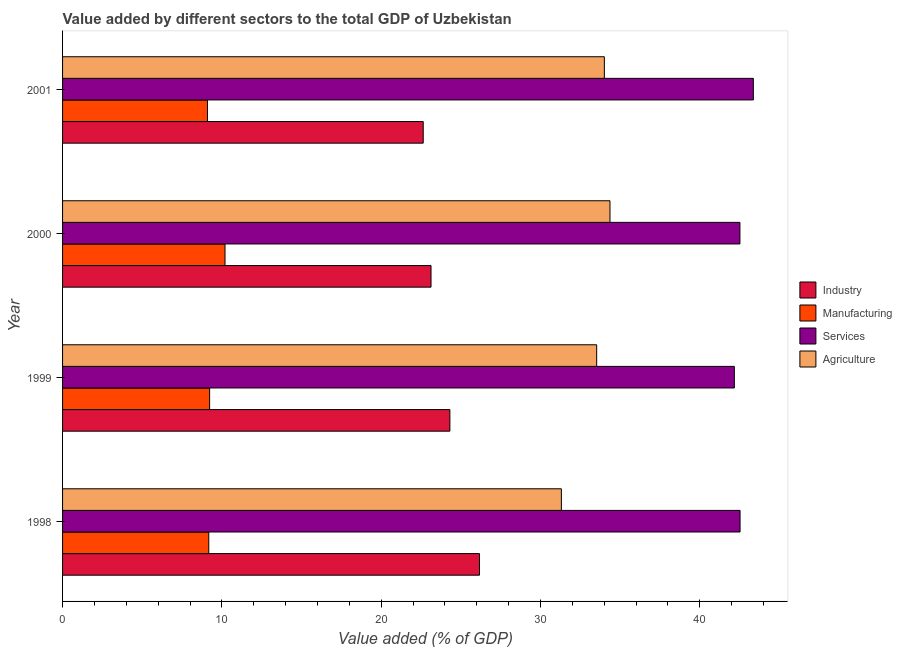How many groups of bars are there?
Give a very brief answer. 4. Are the number of bars per tick equal to the number of legend labels?
Your answer should be very brief. Yes. Are the number of bars on each tick of the Y-axis equal?
Your response must be concise. Yes. How many bars are there on the 3rd tick from the top?
Give a very brief answer. 4. What is the label of the 4th group of bars from the top?
Ensure brevity in your answer.  1998. In how many cases, is the number of bars for a given year not equal to the number of legend labels?
Keep it short and to the point. 0. What is the value added by services sector in 2001?
Offer a terse response. 43.36. Across all years, what is the maximum value added by agricultural sector?
Offer a terse response. 34.36. Across all years, what is the minimum value added by agricultural sector?
Your answer should be compact. 31.31. What is the total value added by agricultural sector in the graph?
Offer a terse response. 133.2. What is the difference between the value added by manufacturing sector in 1998 and that in 2000?
Ensure brevity in your answer.  -1.02. What is the difference between the value added by industrial sector in 2001 and the value added by manufacturing sector in 1998?
Give a very brief answer. 13.46. What is the average value added by manufacturing sector per year?
Offer a terse response. 9.43. In the year 2000, what is the difference between the value added by services sector and value added by manufacturing sector?
Keep it short and to the point. 32.32. In how many years, is the value added by industrial sector greater than 2 %?
Your answer should be very brief. 4. What is the ratio of the value added by agricultural sector in 2000 to that in 2001?
Your answer should be very brief. 1.01. Is the value added by industrial sector in 1998 less than that in 1999?
Your answer should be very brief. No. What is the difference between the highest and the lowest value added by services sector?
Provide a short and direct response. 1.19. In how many years, is the value added by agricultural sector greater than the average value added by agricultural sector taken over all years?
Make the answer very short. 3. Is it the case that in every year, the sum of the value added by services sector and value added by manufacturing sector is greater than the sum of value added by industrial sector and value added by agricultural sector?
Provide a succinct answer. No. What does the 2nd bar from the top in 1998 represents?
Ensure brevity in your answer.  Services. What does the 1st bar from the bottom in 2001 represents?
Ensure brevity in your answer.  Industry. Are all the bars in the graph horizontal?
Your answer should be compact. Yes. How many years are there in the graph?
Give a very brief answer. 4. What is the difference between two consecutive major ticks on the X-axis?
Offer a terse response. 10. Does the graph contain any zero values?
Offer a terse response. No. Does the graph contain grids?
Offer a terse response. No. Where does the legend appear in the graph?
Your answer should be very brief. Center right. What is the title of the graph?
Provide a succinct answer. Value added by different sectors to the total GDP of Uzbekistan. Does "UNDP" appear as one of the legend labels in the graph?
Offer a very short reply. No. What is the label or title of the X-axis?
Offer a very short reply. Value added (% of GDP). What is the label or title of the Y-axis?
Ensure brevity in your answer.  Year. What is the Value added (% of GDP) in Industry in 1998?
Provide a succinct answer. 26.17. What is the Value added (% of GDP) of Manufacturing in 1998?
Make the answer very short. 9.18. What is the Value added (% of GDP) of Services in 1998?
Give a very brief answer. 42.52. What is the Value added (% of GDP) of Agriculture in 1998?
Make the answer very short. 31.31. What is the Value added (% of GDP) of Industry in 1999?
Provide a succinct answer. 24.31. What is the Value added (% of GDP) of Manufacturing in 1999?
Provide a short and direct response. 9.23. What is the Value added (% of GDP) of Services in 1999?
Make the answer very short. 42.17. What is the Value added (% of GDP) in Agriculture in 1999?
Keep it short and to the point. 33.52. What is the Value added (% of GDP) in Industry in 2000?
Offer a terse response. 23.13. What is the Value added (% of GDP) in Manufacturing in 2000?
Provide a succinct answer. 10.2. What is the Value added (% of GDP) of Services in 2000?
Make the answer very short. 42.51. What is the Value added (% of GDP) of Agriculture in 2000?
Make the answer very short. 34.36. What is the Value added (% of GDP) of Industry in 2001?
Your response must be concise. 22.64. What is the Value added (% of GDP) in Manufacturing in 2001?
Offer a very short reply. 9.1. What is the Value added (% of GDP) in Services in 2001?
Ensure brevity in your answer.  43.36. What is the Value added (% of GDP) in Agriculture in 2001?
Your answer should be very brief. 34.01. Across all years, what is the maximum Value added (% of GDP) in Industry?
Offer a terse response. 26.17. Across all years, what is the maximum Value added (% of GDP) in Manufacturing?
Your answer should be very brief. 10.2. Across all years, what is the maximum Value added (% of GDP) in Services?
Your answer should be very brief. 43.36. Across all years, what is the maximum Value added (% of GDP) in Agriculture?
Keep it short and to the point. 34.36. Across all years, what is the minimum Value added (% of GDP) of Industry?
Make the answer very short. 22.64. Across all years, what is the minimum Value added (% of GDP) in Manufacturing?
Your answer should be very brief. 9.1. Across all years, what is the minimum Value added (% of GDP) of Services?
Offer a terse response. 42.17. Across all years, what is the minimum Value added (% of GDP) of Agriculture?
Give a very brief answer. 31.31. What is the total Value added (% of GDP) in Industry in the graph?
Your answer should be very brief. 96.24. What is the total Value added (% of GDP) in Manufacturing in the graph?
Your answer should be compact. 37.7. What is the total Value added (% of GDP) of Services in the graph?
Make the answer very short. 170.56. What is the total Value added (% of GDP) in Agriculture in the graph?
Offer a terse response. 133.2. What is the difference between the Value added (% of GDP) in Industry in 1998 and that in 1999?
Ensure brevity in your answer.  1.86. What is the difference between the Value added (% of GDP) of Manufacturing in 1998 and that in 1999?
Your answer should be very brief. -0.05. What is the difference between the Value added (% of GDP) in Services in 1998 and that in 1999?
Your answer should be compact. 0.36. What is the difference between the Value added (% of GDP) in Agriculture in 1998 and that in 1999?
Give a very brief answer. -2.22. What is the difference between the Value added (% of GDP) in Industry in 1998 and that in 2000?
Provide a short and direct response. 3.04. What is the difference between the Value added (% of GDP) in Manufacturing in 1998 and that in 2000?
Keep it short and to the point. -1.02. What is the difference between the Value added (% of GDP) in Services in 1998 and that in 2000?
Provide a short and direct response. 0.01. What is the difference between the Value added (% of GDP) in Agriculture in 1998 and that in 2000?
Offer a very short reply. -3.05. What is the difference between the Value added (% of GDP) of Industry in 1998 and that in 2001?
Offer a very short reply. 3.53. What is the difference between the Value added (% of GDP) of Manufacturing in 1998 and that in 2001?
Give a very brief answer. 0.08. What is the difference between the Value added (% of GDP) in Services in 1998 and that in 2001?
Give a very brief answer. -0.83. What is the difference between the Value added (% of GDP) in Agriculture in 1998 and that in 2001?
Provide a short and direct response. -2.7. What is the difference between the Value added (% of GDP) of Industry in 1999 and that in 2000?
Offer a very short reply. 1.18. What is the difference between the Value added (% of GDP) of Manufacturing in 1999 and that in 2000?
Your response must be concise. -0.97. What is the difference between the Value added (% of GDP) in Services in 1999 and that in 2000?
Give a very brief answer. -0.35. What is the difference between the Value added (% of GDP) in Agriculture in 1999 and that in 2000?
Make the answer very short. -0.84. What is the difference between the Value added (% of GDP) of Industry in 1999 and that in 2001?
Keep it short and to the point. 1.67. What is the difference between the Value added (% of GDP) in Manufacturing in 1999 and that in 2001?
Your answer should be compact. 0.13. What is the difference between the Value added (% of GDP) in Services in 1999 and that in 2001?
Your response must be concise. -1.19. What is the difference between the Value added (% of GDP) of Agriculture in 1999 and that in 2001?
Offer a very short reply. -0.48. What is the difference between the Value added (% of GDP) of Industry in 2000 and that in 2001?
Offer a terse response. 0.49. What is the difference between the Value added (% of GDP) in Manufacturing in 2000 and that in 2001?
Provide a short and direct response. 1.1. What is the difference between the Value added (% of GDP) in Services in 2000 and that in 2001?
Your answer should be compact. -0.84. What is the difference between the Value added (% of GDP) in Agriculture in 2000 and that in 2001?
Offer a terse response. 0.35. What is the difference between the Value added (% of GDP) of Industry in 1998 and the Value added (% of GDP) of Manufacturing in 1999?
Provide a short and direct response. 16.94. What is the difference between the Value added (% of GDP) of Industry in 1998 and the Value added (% of GDP) of Services in 1999?
Give a very brief answer. -16. What is the difference between the Value added (% of GDP) of Industry in 1998 and the Value added (% of GDP) of Agriculture in 1999?
Your answer should be compact. -7.36. What is the difference between the Value added (% of GDP) in Manufacturing in 1998 and the Value added (% of GDP) in Services in 1999?
Give a very brief answer. -32.99. What is the difference between the Value added (% of GDP) in Manufacturing in 1998 and the Value added (% of GDP) in Agriculture in 1999?
Make the answer very short. -24.35. What is the difference between the Value added (% of GDP) in Services in 1998 and the Value added (% of GDP) in Agriculture in 1999?
Keep it short and to the point. 9. What is the difference between the Value added (% of GDP) in Industry in 1998 and the Value added (% of GDP) in Manufacturing in 2000?
Keep it short and to the point. 15.97. What is the difference between the Value added (% of GDP) of Industry in 1998 and the Value added (% of GDP) of Services in 2000?
Your answer should be compact. -16.35. What is the difference between the Value added (% of GDP) of Industry in 1998 and the Value added (% of GDP) of Agriculture in 2000?
Your response must be concise. -8.19. What is the difference between the Value added (% of GDP) of Manufacturing in 1998 and the Value added (% of GDP) of Services in 2000?
Provide a short and direct response. -33.34. What is the difference between the Value added (% of GDP) of Manufacturing in 1998 and the Value added (% of GDP) of Agriculture in 2000?
Your answer should be compact. -25.18. What is the difference between the Value added (% of GDP) of Services in 1998 and the Value added (% of GDP) of Agriculture in 2000?
Ensure brevity in your answer.  8.16. What is the difference between the Value added (% of GDP) in Industry in 1998 and the Value added (% of GDP) in Manufacturing in 2001?
Keep it short and to the point. 17.07. What is the difference between the Value added (% of GDP) of Industry in 1998 and the Value added (% of GDP) of Services in 2001?
Offer a very short reply. -17.19. What is the difference between the Value added (% of GDP) in Industry in 1998 and the Value added (% of GDP) in Agriculture in 2001?
Ensure brevity in your answer.  -7.84. What is the difference between the Value added (% of GDP) of Manufacturing in 1998 and the Value added (% of GDP) of Services in 2001?
Your response must be concise. -34.18. What is the difference between the Value added (% of GDP) in Manufacturing in 1998 and the Value added (% of GDP) in Agriculture in 2001?
Your answer should be very brief. -24.83. What is the difference between the Value added (% of GDP) of Services in 1998 and the Value added (% of GDP) of Agriculture in 2001?
Your answer should be very brief. 8.52. What is the difference between the Value added (% of GDP) of Industry in 1999 and the Value added (% of GDP) of Manufacturing in 2000?
Make the answer very short. 14.11. What is the difference between the Value added (% of GDP) of Industry in 1999 and the Value added (% of GDP) of Services in 2000?
Make the answer very short. -18.2. What is the difference between the Value added (% of GDP) of Industry in 1999 and the Value added (% of GDP) of Agriculture in 2000?
Provide a short and direct response. -10.05. What is the difference between the Value added (% of GDP) in Manufacturing in 1999 and the Value added (% of GDP) in Services in 2000?
Make the answer very short. -33.28. What is the difference between the Value added (% of GDP) in Manufacturing in 1999 and the Value added (% of GDP) in Agriculture in 2000?
Keep it short and to the point. -25.13. What is the difference between the Value added (% of GDP) of Services in 1999 and the Value added (% of GDP) of Agriculture in 2000?
Offer a very short reply. 7.81. What is the difference between the Value added (% of GDP) of Industry in 1999 and the Value added (% of GDP) of Manufacturing in 2001?
Your answer should be very brief. 15.21. What is the difference between the Value added (% of GDP) of Industry in 1999 and the Value added (% of GDP) of Services in 2001?
Your response must be concise. -19.05. What is the difference between the Value added (% of GDP) in Industry in 1999 and the Value added (% of GDP) in Agriculture in 2001?
Keep it short and to the point. -9.7. What is the difference between the Value added (% of GDP) of Manufacturing in 1999 and the Value added (% of GDP) of Services in 2001?
Your answer should be compact. -34.13. What is the difference between the Value added (% of GDP) of Manufacturing in 1999 and the Value added (% of GDP) of Agriculture in 2001?
Your answer should be compact. -24.77. What is the difference between the Value added (% of GDP) of Services in 1999 and the Value added (% of GDP) of Agriculture in 2001?
Make the answer very short. 8.16. What is the difference between the Value added (% of GDP) of Industry in 2000 and the Value added (% of GDP) of Manufacturing in 2001?
Make the answer very short. 14.03. What is the difference between the Value added (% of GDP) of Industry in 2000 and the Value added (% of GDP) of Services in 2001?
Give a very brief answer. -20.23. What is the difference between the Value added (% of GDP) in Industry in 2000 and the Value added (% of GDP) in Agriculture in 2001?
Your response must be concise. -10.88. What is the difference between the Value added (% of GDP) of Manufacturing in 2000 and the Value added (% of GDP) of Services in 2001?
Give a very brief answer. -33.16. What is the difference between the Value added (% of GDP) of Manufacturing in 2000 and the Value added (% of GDP) of Agriculture in 2001?
Offer a terse response. -23.81. What is the difference between the Value added (% of GDP) in Services in 2000 and the Value added (% of GDP) in Agriculture in 2001?
Keep it short and to the point. 8.51. What is the average Value added (% of GDP) of Industry per year?
Your response must be concise. 24.06. What is the average Value added (% of GDP) in Manufacturing per year?
Your answer should be very brief. 9.43. What is the average Value added (% of GDP) in Services per year?
Your answer should be very brief. 42.64. What is the average Value added (% of GDP) of Agriculture per year?
Your answer should be compact. 33.3. In the year 1998, what is the difference between the Value added (% of GDP) of Industry and Value added (% of GDP) of Manufacturing?
Give a very brief answer. 16.99. In the year 1998, what is the difference between the Value added (% of GDP) of Industry and Value added (% of GDP) of Services?
Keep it short and to the point. -16.36. In the year 1998, what is the difference between the Value added (% of GDP) in Industry and Value added (% of GDP) in Agriculture?
Make the answer very short. -5.14. In the year 1998, what is the difference between the Value added (% of GDP) in Manufacturing and Value added (% of GDP) in Services?
Make the answer very short. -33.35. In the year 1998, what is the difference between the Value added (% of GDP) of Manufacturing and Value added (% of GDP) of Agriculture?
Make the answer very short. -22.13. In the year 1998, what is the difference between the Value added (% of GDP) in Services and Value added (% of GDP) in Agriculture?
Provide a short and direct response. 11.21. In the year 1999, what is the difference between the Value added (% of GDP) in Industry and Value added (% of GDP) in Manufacturing?
Your response must be concise. 15.08. In the year 1999, what is the difference between the Value added (% of GDP) of Industry and Value added (% of GDP) of Services?
Keep it short and to the point. -17.86. In the year 1999, what is the difference between the Value added (% of GDP) of Industry and Value added (% of GDP) of Agriculture?
Give a very brief answer. -9.21. In the year 1999, what is the difference between the Value added (% of GDP) of Manufacturing and Value added (% of GDP) of Services?
Your answer should be very brief. -32.94. In the year 1999, what is the difference between the Value added (% of GDP) in Manufacturing and Value added (% of GDP) in Agriculture?
Your response must be concise. -24.29. In the year 1999, what is the difference between the Value added (% of GDP) of Services and Value added (% of GDP) of Agriculture?
Ensure brevity in your answer.  8.64. In the year 2000, what is the difference between the Value added (% of GDP) in Industry and Value added (% of GDP) in Manufacturing?
Provide a short and direct response. 12.93. In the year 2000, what is the difference between the Value added (% of GDP) of Industry and Value added (% of GDP) of Services?
Provide a succinct answer. -19.39. In the year 2000, what is the difference between the Value added (% of GDP) in Industry and Value added (% of GDP) in Agriculture?
Offer a terse response. -11.23. In the year 2000, what is the difference between the Value added (% of GDP) in Manufacturing and Value added (% of GDP) in Services?
Give a very brief answer. -32.32. In the year 2000, what is the difference between the Value added (% of GDP) in Manufacturing and Value added (% of GDP) in Agriculture?
Provide a succinct answer. -24.16. In the year 2000, what is the difference between the Value added (% of GDP) in Services and Value added (% of GDP) in Agriculture?
Provide a short and direct response. 8.16. In the year 2001, what is the difference between the Value added (% of GDP) of Industry and Value added (% of GDP) of Manufacturing?
Ensure brevity in your answer.  13.54. In the year 2001, what is the difference between the Value added (% of GDP) of Industry and Value added (% of GDP) of Services?
Keep it short and to the point. -20.72. In the year 2001, what is the difference between the Value added (% of GDP) in Industry and Value added (% of GDP) in Agriculture?
Provide a short and direct response. -11.37. In the year 2001, what is the difference between the Value added (% of GDP) in Manufacturing and Value added (% of GDP) in Services?
Your answer should be very brief. -34.26. In the year 2001, what is the difference between the Value added (% of GDP) in Manufacturing and Value added (% of GDP) in Agriculture?
Offer a terse response. -24.91. In the year 2001, what is the difference between the Value added (% of GDP) of Services and Value added (% of GDP) of Agriculture?
Keep it short and to the point. 9.35. What is the ratio of the Value added (% of GDP) of Industry in 1998 to that in 1999?
Your response must be concise. 1.08. What is the ratio of the Value added (% of GDP) of Manufacturing in 1998 to that in 1999?
Make the answer very short. 0.99. What is the ratio of the Value added (% of GDP) in Services in 1998 to that in 1999?
Make the answer very short. 1.01. What is the ratio of the Value added (% of GDP) of Agriculture in 1998 to that in 1999?
Your response must be concise. 0.93. What is the ratio of the Value added (% of GDP) of Industry in 1998 to that in 2000?
Ensure brevity in your answer.  1.13. What is the ratio of the Value added (% of GDP) of Manufacturing in 1998 to that in 2000?
Your answer should be very brief. 0.9. What is the ratio of the Value added (% of GDP) of Services in 1998 to that in 2000?
Your response must be concise. 1. What is the ratio of the Value added (% of GDP) of Agriculture in 1998 to that in 2000?
Your response must be concise. 0.91. What is the ratio of the Value added (% of GDP) of Industry in 1998 to that in 2001?
Make the answer very short. 1.16. What is the ratio of the Value added (% of GDP) of Manufacturing in 1998 to that in 2001?
Give a very brief answer. 1.01. What is the ratio of the Value added (% of GDP) in Services in 1998 to that in 2001?
Offer a terse response. 0.98. What is the ratio of the Value added (% of GDP) in Agriculture in 1998 to that in 2001?
Keep it short and to the point. 0.92. What is the ratio of the Value added (% of GDP) in Industry in 1999 to that in 2000?
Your answer should be compact. 1.05. What is the ratio of the Value added (% of GDP) in Manufacturing in 1999 to that in 2000?
Offer a very short reply. 0.91. What is the ratio of the Value added (% of GDP) in Services in 1999 to that in 2000?
Your answer should be very brief. 0.99. What is the ratio of the Value added (% of GDP) of Agriculture in 1999 to that in 2000?
Your answer should be compact. 0.98. What is the ratio of the Value added (% of GDP) in Industry in 1999 to that in 2001?
Offer a very short reply. 1.07. What is the ratio of the Value added (% of GDP) in Manufacturing in 1999 to that in 2001?
Provide a succinct answer. 1.01. What is the ratio of the Value added (% of GDP) of Services in 1999 to that in 2001?
Provide a succinct answer. 0.97. What is the ratio of the Value added (% of GDP) of Agriculture in 1999 to that in 2001?
Your answer should be compact. 0.99. What is the ratio of the Value added (% of GDP) in Industry in 2000 to that in 2001?
Your answer should be very brief. 1.02. What is the ratio of the Value added (% of GDP) of Manufacturing in 2000 to that in 2001?
Make the answer very short. 1.12. What is the ratio of the Value added (% of GDP) in Services in 2000 to that in 2001?
Offer a very short reply. 0.98. What is the ratio of the Value added (% of GDP) in Agriculture in 2000 to that in 2001?
Make the answer very short. 1.01. What is the difference between the highest and the second highest Value added (% of GDP) of Industry?
Provide a short and direct response. 1.86. What is the difference between the highest and the second highest Value added (% of GDP) of Manufacturing?
Offer a very short reply. 0.97. What is the difference between the highest and the second highest Value added (% of GDP) of Services?
Keep it short and to the point. 0.83. What is the difference between the highest and the second highest Value added (% of GDP) of Agriculture?
Make the answer very short. 0.35. What is the difference between the highest and the lowest Value added (% of GDP) of Industry?
Keep it short and to the point. 3.53. What is the difference between the highest and the lowest Value added (% of GDP) of Manufacturing?
Keep it short and to the point. 1.1. What is the difference between the highest and the lowest Value added (% of GDP) in Services?
Keep it short and to the point. 1.19. What is the difference between the highest and the lowest Value added (% of GDP) of Agriculture?
Offer a very short reply. 3.05. 